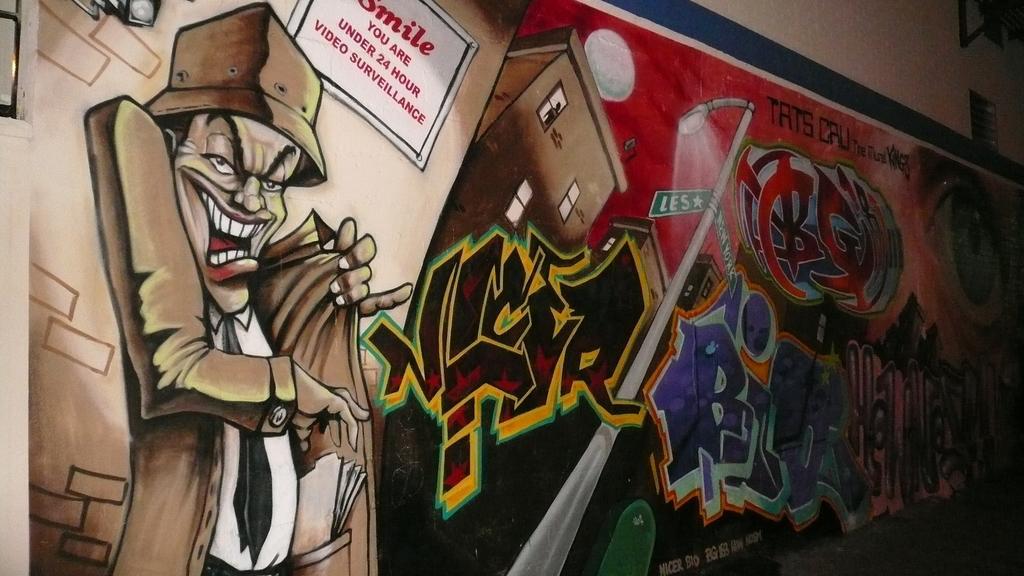What is shown on the hoarding in the image? There is a building depicted on the hoarding. Are there any characters or figures on the hoarding? Yes, there is an animated person on the hoarding. What else can be seen on the hoarding besides the building and the person? There is a light pole on the hoarding. Is there any text or writing on the hoarding? Yes, there is text or writing on the hoarding. Can you see any pies being baked in the image? There is no reference to pies or baking in the image; it features a hoarding with a building, an animated person, a light pole, and text or writing. Are there any giraffes visible on the plantation in the image? There is no plantation or giraffes present in the image; it features a hoarding with a building, an animated person, a light pole, and text or writing. 